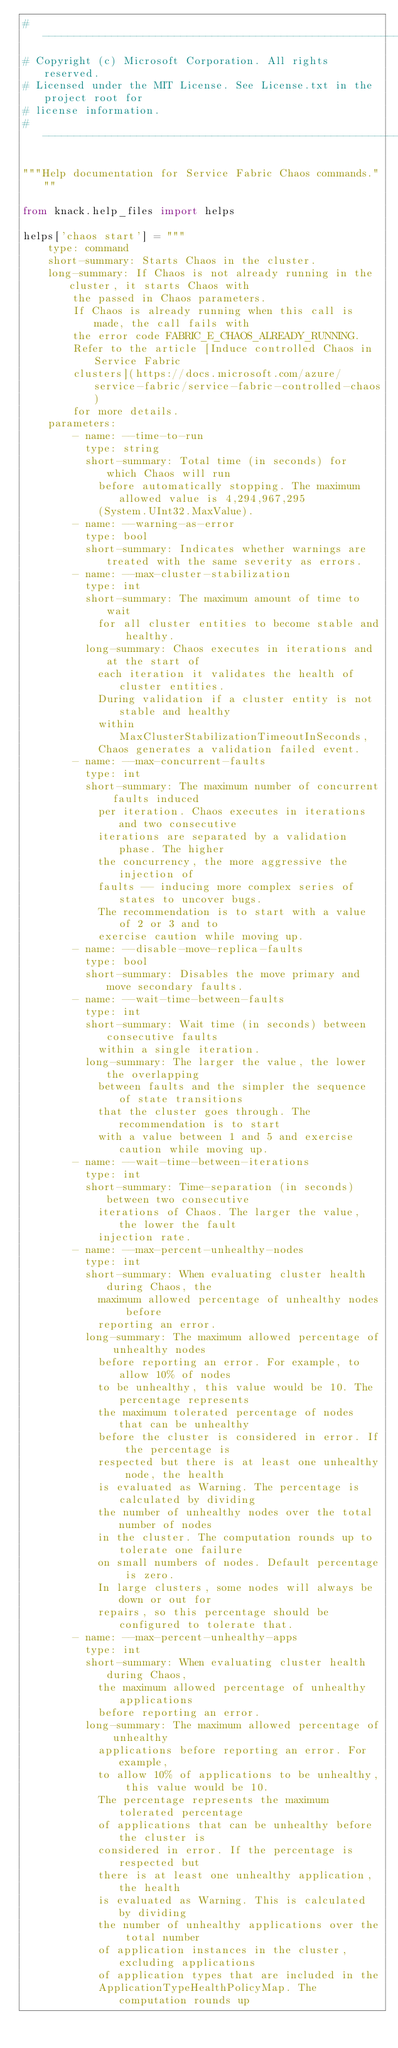Convert code to text. <code><loc_0><loc_0><loc_500><loc_500><_Python_># -----------------------------------------------------------------------------
# Copyright (c) Microsoft Corporation. All rights reserved.
# Licensed under the MIT License. See License.txt in the project root for
# license information.
# -----------------------------------------------------------------------------

"""Help documentation for Service Fabric Chaos commands."""

from knack.help_files import helps

helps['chaos start'] = """
    type: command
    short-summary: Starts Chaos in the cluster.
    long-summary: If Chaos is not already running in the cluster, it starts Chaos with
        the passed in Chaos parameters.
        If Chaos is already running when this call is made, the call fails with
        the error code FABRIC_E_CHAOS_ALREADY_RUNNING.
        Refer to the article [Induce controlled Chaos in Service Fabric
        clusters](https://docs.microsoft.com/azure/service-fabric/service-fabric-controlled-chaos)
        for more details.
    parameters:
        - name: --time-to-run
          type: string
          short-summary: Total time (in seconds) for which Chaos will run
            before automatically stopping. The maximum allowed value is 4,294,967,295
            (System.UInt32.MaxValue).
        - name: --warning-as-error
          type: bool
          short-summary: Indicates whether warnings are treated with the same severity as errors.
        - name: --max-cluster-stabilization
          type: int
          short-summary: The maximum amount of time to wait
            for all cluster entities to become stable and healthy.
          long-summary: Chaos executes in iterations and at the start of
            each iteration it validates the health of cluster entities.
            During validation if a cluster entity is not stable and healthy
            within MaxClusterStabilizationTimeoutInSeconds,
            Chaos generates a validation failed event.
        - name: --max-concurrent-faults
          type: int
          short-summary: The maximum number of concurrent faults induced
            per iteration. Chaos executes in iterations and two consecutive
            iterations are separated by a validation phase. The higher
            the concurrency, the more aggressive the injection of
            faults -- inducing more complex series of states to uncover bugs.
            The recommendation is to start with a value of 2 or 3 and to
            exercise caution while moving up.
        - name: --disable-move-replica-faults
          type: bool
          short-summary: Disables the move primary and move secondary faults.
        - name: --wait-time-between-faults
          type: int
          short-summary: Wait time (in seconds) between consecutive faults
            within a single iteration.
          long-summary: The larger the value, the lower the overlapping
            between faults and the simpler the sequence of state transitions
            that the cluster goes through. The recommendation is to start
            with a value between 1 and 5 and exercise caution while moving up.
        - name: --wait-time-between-iterations
          type: int
          short-summary: Time-separation (in seconds) between two consecutive
            iterations of Chaos. The larger the value, the lower the fault
            injection rate.
        - name: --max-percent-unhealthy-nodes
          type: int
          short-summary: When evaluating cluster health during Chaos, the
            maximum allowed percentage of unhealthy nodes before
            reporting an error.
          long-summary: The maximum allowed percentage of unhealthy nodes
            before reporting an error. For example, to allow 10% of nodes
            to be unhealthy, this value would be 10. The percentage represents
            the maximum tolerated percentage of nodes that can be unhealthy
            before the cluster is considered in error. If the percentage is
            respected but there is at least one unhealthy node, the health
            is evaluated as Warning. The percentage is calculated by dividing
            the number of unhealthy nodes over the total number of nodes
            in the cluster. The computation rounds up to tolerate one failure
            on small numbers of nodes. Default percentage is zero.
            In large clusters, some nodes will always be down or out for
            repairs, so this percentage should be configured to tolerate that.
        - name: --max-percent-unhealthy-apps
          type: int
          short-summary: When evaluating cluster health during Chaos,
            the maximum allowed percentage of unhealthy applications
            before reporting an error.
          long-summary: The maximum allowed percentage of unhealthy
            applications before reporting an error. For example,
            to allow 10% of applications to be unhealthy, this value would be 10.
            The percentage represents the maximum tolerated percentage
            of applications that can be unhealthy before the cluster is
            considered in error. If the percentage is respected but
            there is at least one unhealthy application, the health
            is evaluated as Warning. This is calculated by dividing
            the number of unhealthy applications over the total number
            of application instances in the cluster, excluding applications
            of application types that are included in the
            ApplicationTypeHealthPolicyMap. The computation rounds up</code> 